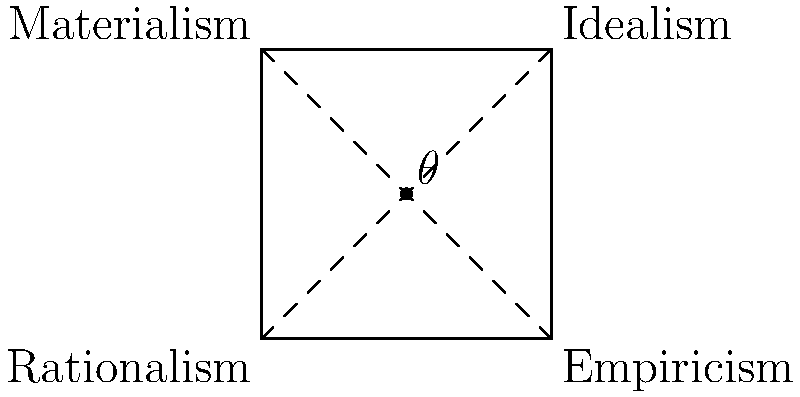In the square diagram representing the relationships between rationalism, empiricism, idealism, and materialism, what is the measure of angle $\theta$ formed at the intersection of the diagonals? To determine the measure of angle $\theta$, let's follow these steps:

1. Recognize that the diagram is a square, which has four right angles (90°) at its corners.

2. The diagonals of a square bisect each other and form four congruent triangles.

3. In a square, the diagonals are perpendicular to each other, forming four 90° angles at their intersection point.

4. The angle $\theta$ is one of these four angles formed by the intersecting diagonals.

5. Therefore, the measure of angle $\theta$ is 90°.

This geometric representation illustrates the complex relationships between these philosophical concepts:

- The perpendicular diagonals suggest the fundamental tensions between rationalism and empiricism (as ways of acquiring knowledge) and between idealism and materialism (as ontological perspectives).
- The equal size of the triangles formed by the diagonals implies that these philosophical approaches are equally valid or significant in their contributions to understanding reality and knowledge.
- The central intersection point where $\theta$ is located could represent a balanced philosophical viewpoint that considers all four perspectives.
Answer: 90° 